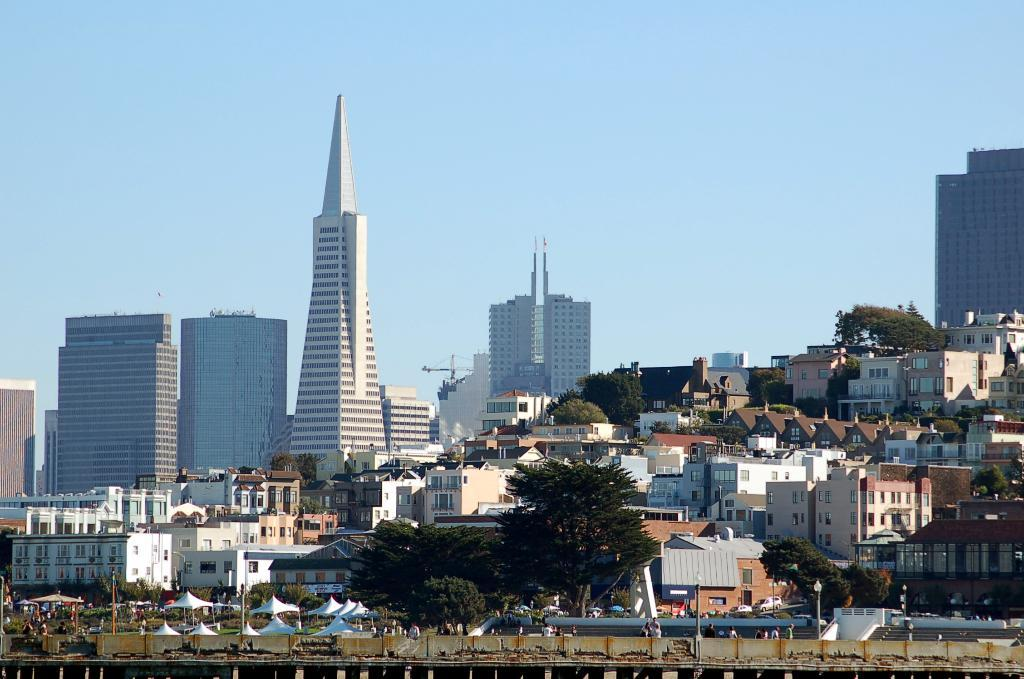What type of structures can be seen in the image? There are buildings in the image. What other natural elements are present in the image? There are trees in the image. Are there any living beings visible in the image? Yes, there are people in the image. What are the poles used for in the image? The poles are likely used for support or as markers in the image. Can you describe any other objects present in the image? There are other objects in the image, but their specific purpose or appearance is not mentioned in the facts. What is visible at the top of the image? The sky is visible at the top of the image. What type of infrastructure is present at the bottom of the image? There is a bridge at the bottom of the image. How do the pests affect the buildings in the image? There is no mention of pests in the image, so we cannot determine their effect on the buildings. What trick is being performed by the people in the image? There is no indication of a trick being performed by the people in the image. 